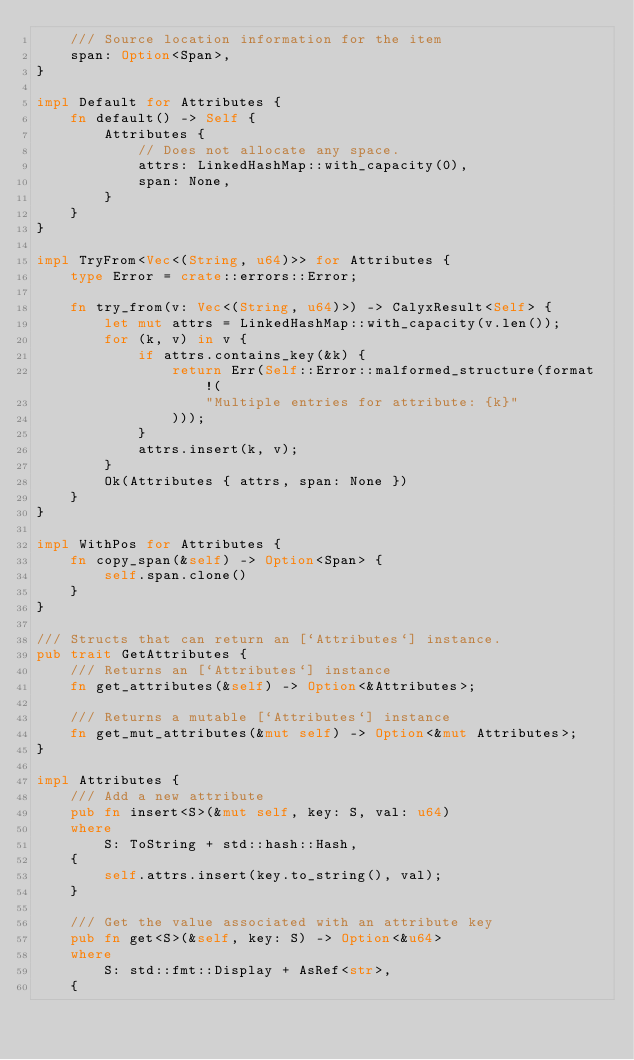Convert code to text. <code><loc_0><loc_0><loc_500><loc_500><_Rust_>    /// Source location information for the item
    span: Option<Span>,
}

impl Default for Attributes {
    fn default() -> Self {
        Attributes {
            // Does not allocate any space.
            attrs: LinkedHashMap::with_capacity(0),
            span: None,
        }
    }
}

impl TryFrom<Vec<(String, u64)>> for Attributes {
    type Error = crate::errors::Error;

    fn try_from(v: Vec<(String, u64)>) -> CalyxResult<Self> {
        let mut attrs = LinkedHashMap::with_capacity(v.len());
        for (k, v) in v {
            if attrs.contains_key(&k) {
                return Err(Self::Error::malformed_structure(format!(
                    "Multiple entries for attribute: {k}"
                )));
            }
            attrs.insert(k, v);
        }
        Ok(Attributes { attrs, span: None })
    }
}

impl WithPos for Attributes {
    fn copy_span(&self) -> Option<Span> {
        self.span.clone()
    }
}

/// Structs that can return an [`Attributes`] instance.
pub trait GetAttributes {
    /// Returns an [`Attributes`] instance
    fn get_attributes(&self) -> Option<&Attributes>;

    /// Returns a mutable [`Attributes`] instance
    fn get_mut_attributes(&mut self) -> Option<&mut Attributes>;
}

impl Attributes {
    /// Add a new attribute
    pub fn insert<S>(&mut self, key: S, val: u64)
    where
        S: ToString + std::hash::Hash,
    {
        self.attrs.insert(key.to_string(), val);
    }

    /// Get the value associated with an attribute key
    pub fn get<S>(&self, key: S) -> Option<&u64>
    where
        S: std::fmt::Display + AsRef<str>,
    {</code> 